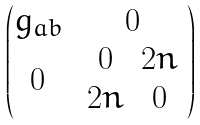<formula> <loc_0><loc_0><loc_500><loc_500>\begin{pmatrix} g _ { a b } & 0 \\ 0 & \begin{array} { c c } 0 & 2 n \\ 2 n & 0 \end{array} \end{pmatrix}</formula> 